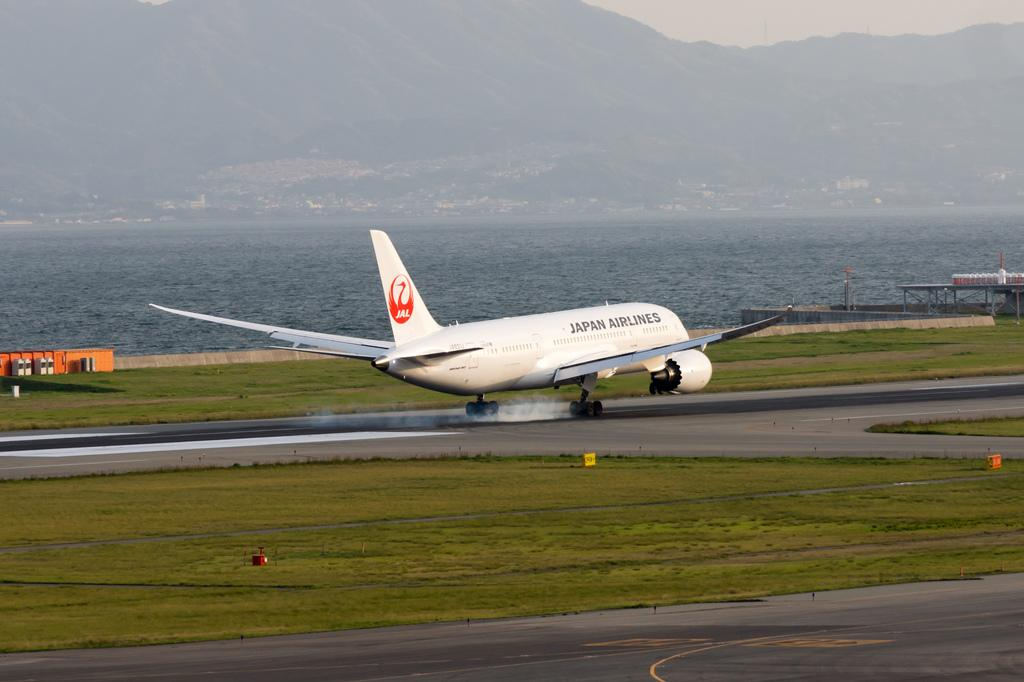<image>
Render a clear and concise summary of the photo. A JAL airplane is going down the runway. 